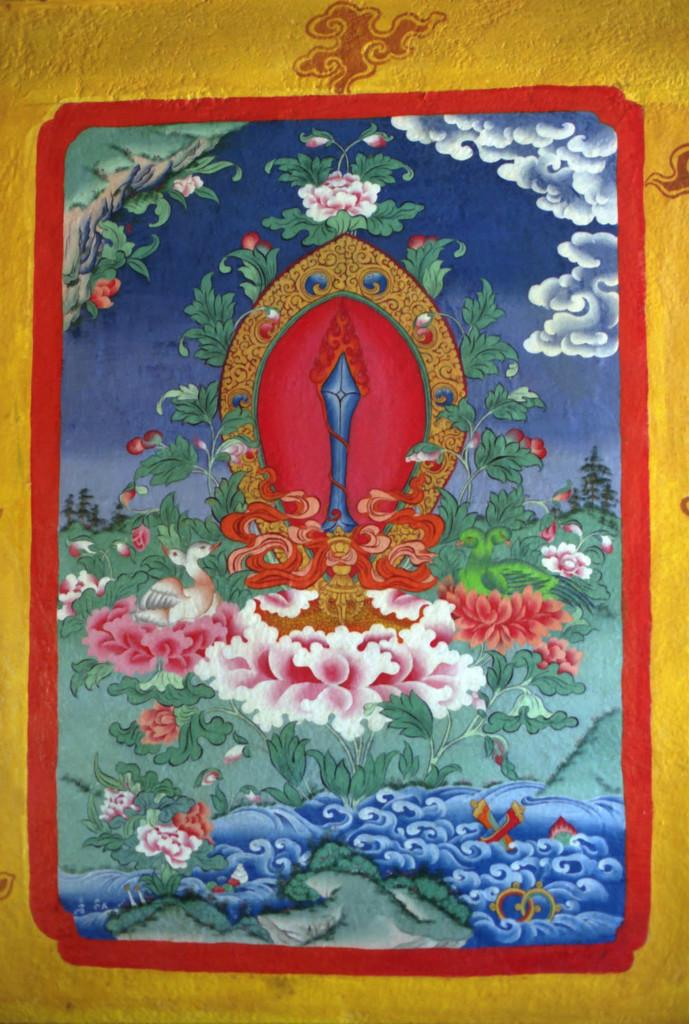What is depicted on the paper in the image? There is a painting on the paper. What elements can be found in the painting? The painting contains trees, flowers, water, and clouds. What type of business is being conducted in the painting? There is no indication of any business activity in the painting; it primarily features natural elements such as trees, flowers, water, and clouds. 